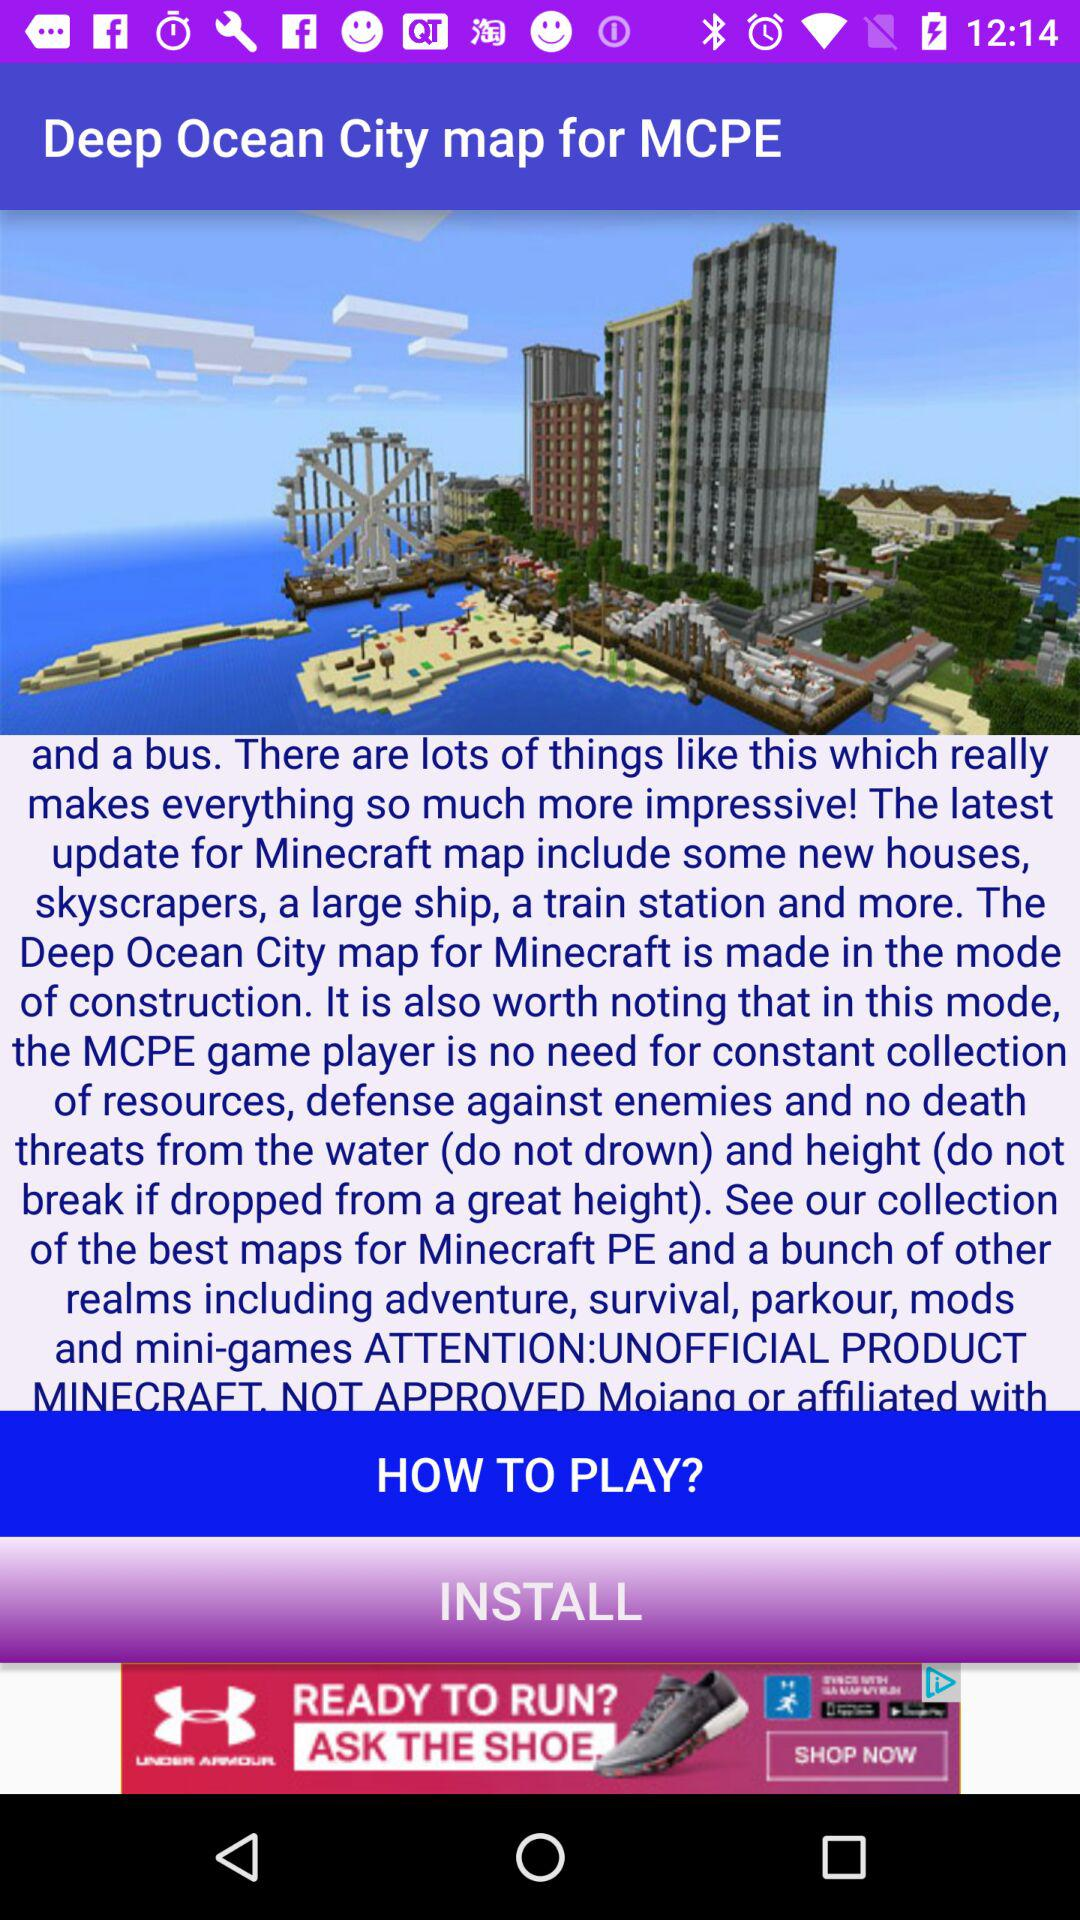What is the name of the gaming application?
When the provided information is insufficient, respond with <no answer>. <no answer> 